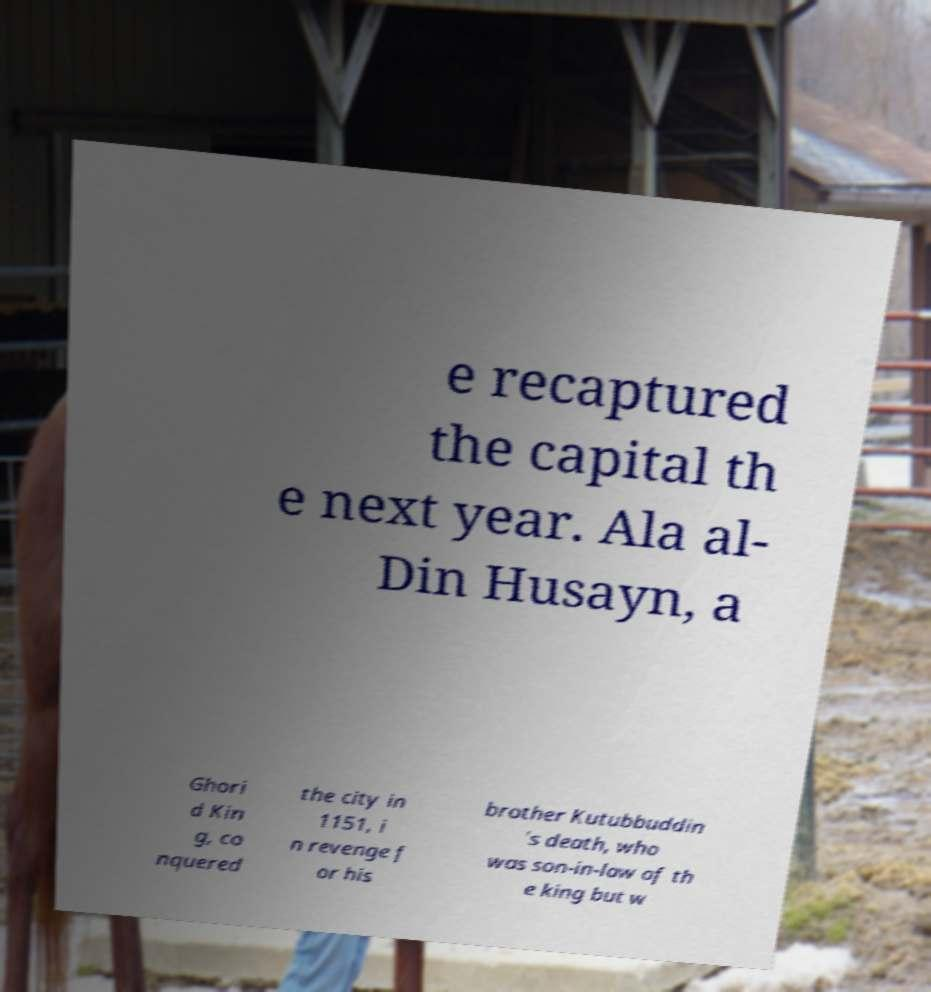Please identify and transcribe the text found in this image. e recaptured the capital th e next year. Ala al- Din Husayn, a Ghori d Kin g, co nquered the city in 1151, i n revenge f or his brother Kutubbuddin 's death, who was son-in-law of th e king but w 